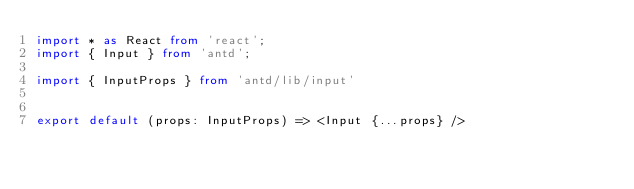<code> <loc_0><loc_0><loc_500><loc_500><_TypeScript_>import * as React from 'react';
import { Input } from 'antd';

import { InputProps } from 'antd/lib/input'


export default (props: InputProps) => <Input {...props} /></code> 